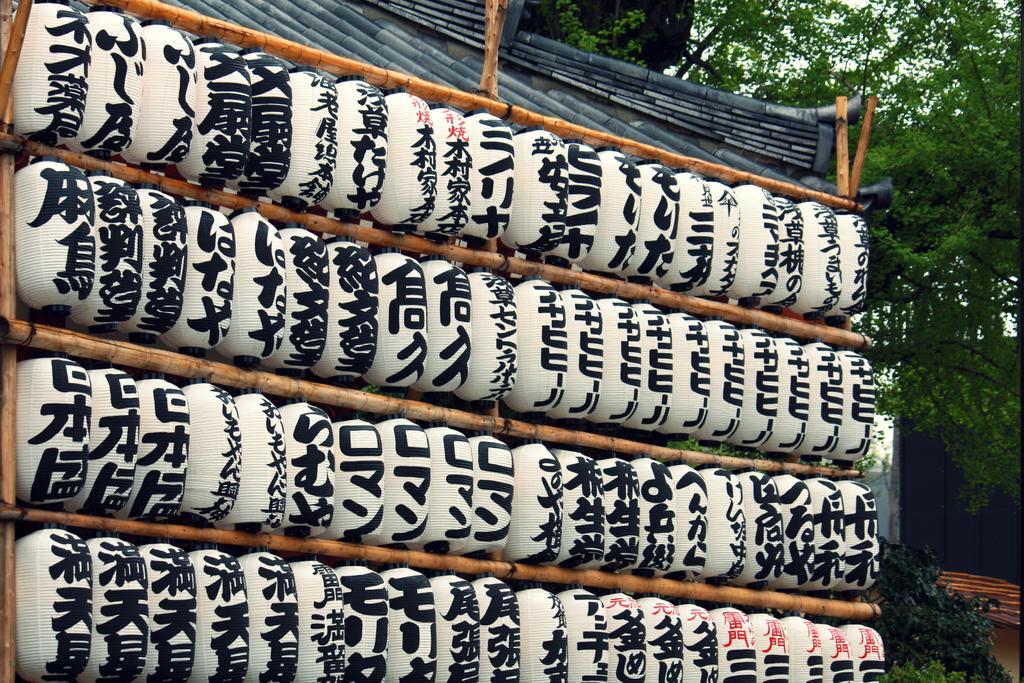Could you give a brief overview of what you see in this image? In this image, I can see the Chinese text on the lanterns, which are hanging to the wooden sticks. At the top of the image, I can see the roof. On the right side of the image, It looks like a house and there are trees. In the background, there is the sky. 